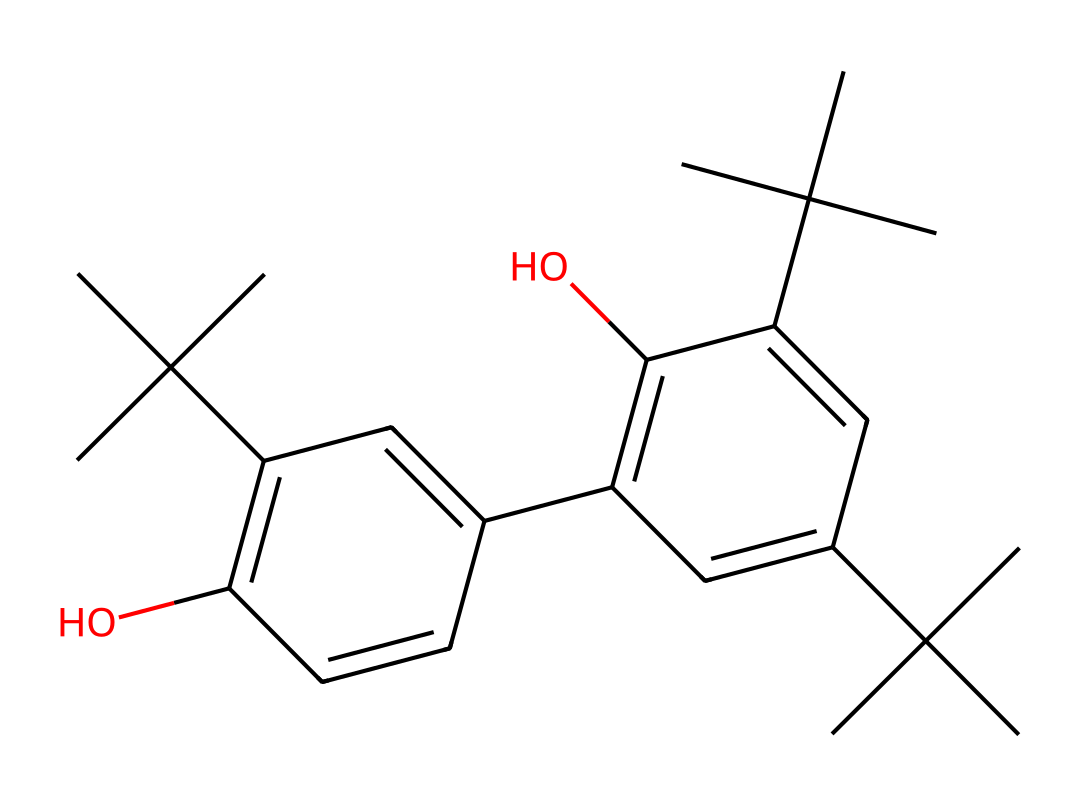What is the molecular formula of this chemical? To determine the molecular formula, we need to count the number of carbon (C), hydrogen (H), and oxygen (O) atoms present in the SMILES representation. By analyzing the structure, we can find that there are 24 carbon atoms, 38 hydrogen atoms, and 4 oxygen atoms. Therefore, the molecular formula is C24H38O4.
Answer: C24H38O4 How many rings are present in this structure? By examining the SMILES, we can identify ring structures by looking for repeating numbers that indicate the start and end of a ring. In this case, there are two sets of numbers, indicating two rings are present in the structure.
Answer: 2 What type of functional groups are present in this chemical? The presence of '-OH' groups in the structure signifies the presence of alcohol functional groups. Additionally, the presence of carbon rings and various carbon attachments indicates it belongs to a class of chemicals known as phenols. In total, there are two hydroxyl (-OH) functional groups in this structure.
Answer: alcohol, phenol What is the type of the chemical represented by this structure? This chemical, based on its composition which includes multiple phenolic structures, is primarily classified as a polyphenolic compound commonly used in plastics.
Answer: polyphenolic What are the physical properties suggested by the presence of multiple branched chains? The multiple branched chains in the structure typically suggest that the chemical could have low density and improved flexibility, which are common characteristics of plastics. These properties contribute to materials that are durable and lightweight.
Answer: low density, flexibility 